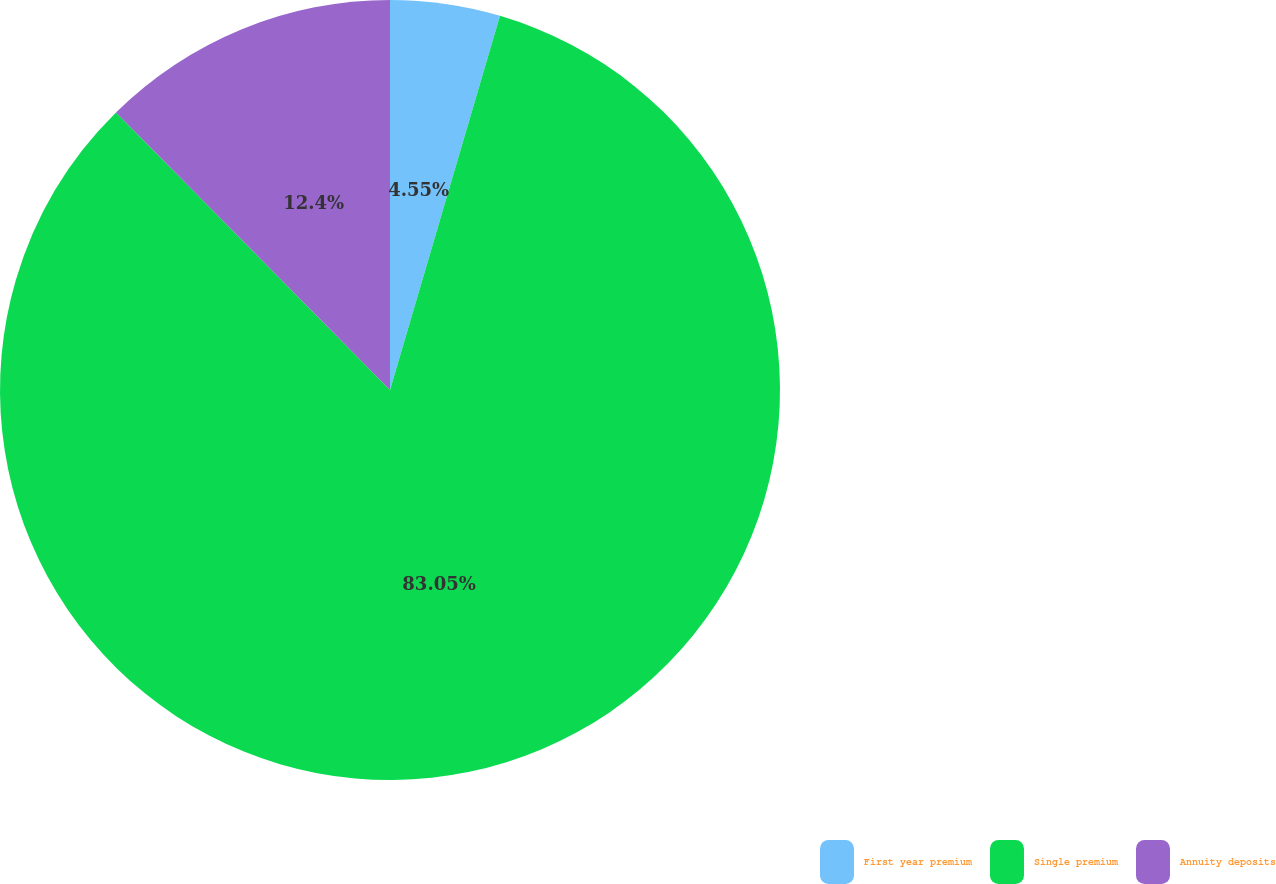Convert chart. <chart><loc_0><loc_0><loc_500><loc_500><pie_chart><fcel>First year premium<fcel>Single premium<fcel>Annuity deposits<nl><fcel>4.55%<fcel>83.06%<fcel>12.4%<nl></chart> 